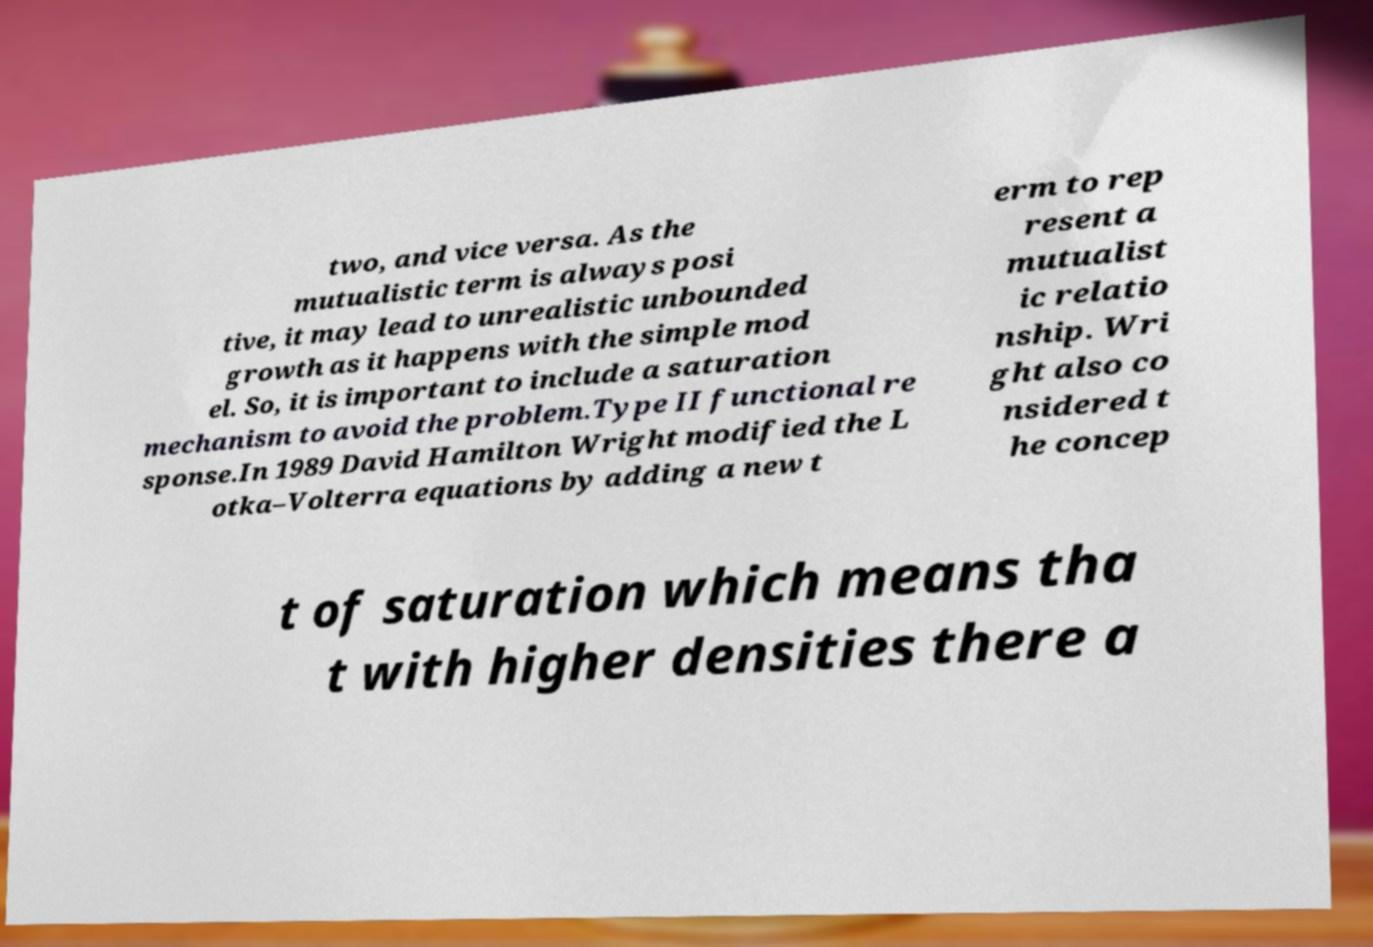Can you accurately transcribe the text from the provided image for me? two, and vice versa. As the mutualistic term is always posi tive, it may lead to unrealistic unbounded growth as it happens with the simple mod el. So, it is important to include a saturation mechanism to avoid the problem.Type II functional re sponse.In 1989 David Hamilton Wright modified the L otka–Volterra equations by adding a new t erm to rep resent a mutualist ic relatio nship. Wri ght also co nsidered t he concep t of saturation which means tha t with higher densities there a 